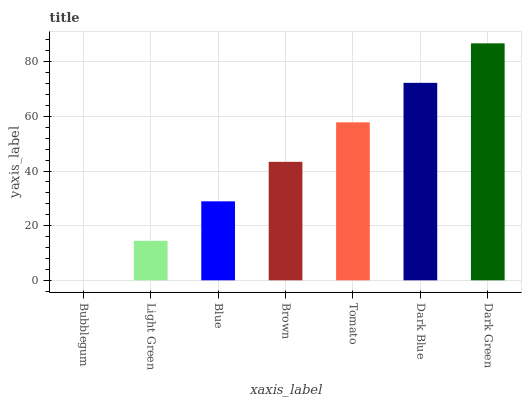Is Bubblegum the minimum?
Answer yes or no. Yes. Is Dark Green the maximum?
Answer yes or no. Yes. Is Light Green the minimum?
Answer yes or no. No. Is Light Green the maximum?
Answer yes or no. No. Is Light Green greater than Bubblegum?
Answer yes or no. Yes. Is Bubblegum less than Light Green?
Answer yes or no. Yes. Is Bubblegum greater than Light Green?
Answer yes or no. No. Is Light Green less than Bubblegum?
Answer yes or no. No. Is Brown the high median?
Answer yes or no. Yes. Is Brown the low median?
Answer yes or no. Yes. Is Blue the high median?
Answer yes or no. No. Is Dark Green the low median?
Answer yes or no. No. 